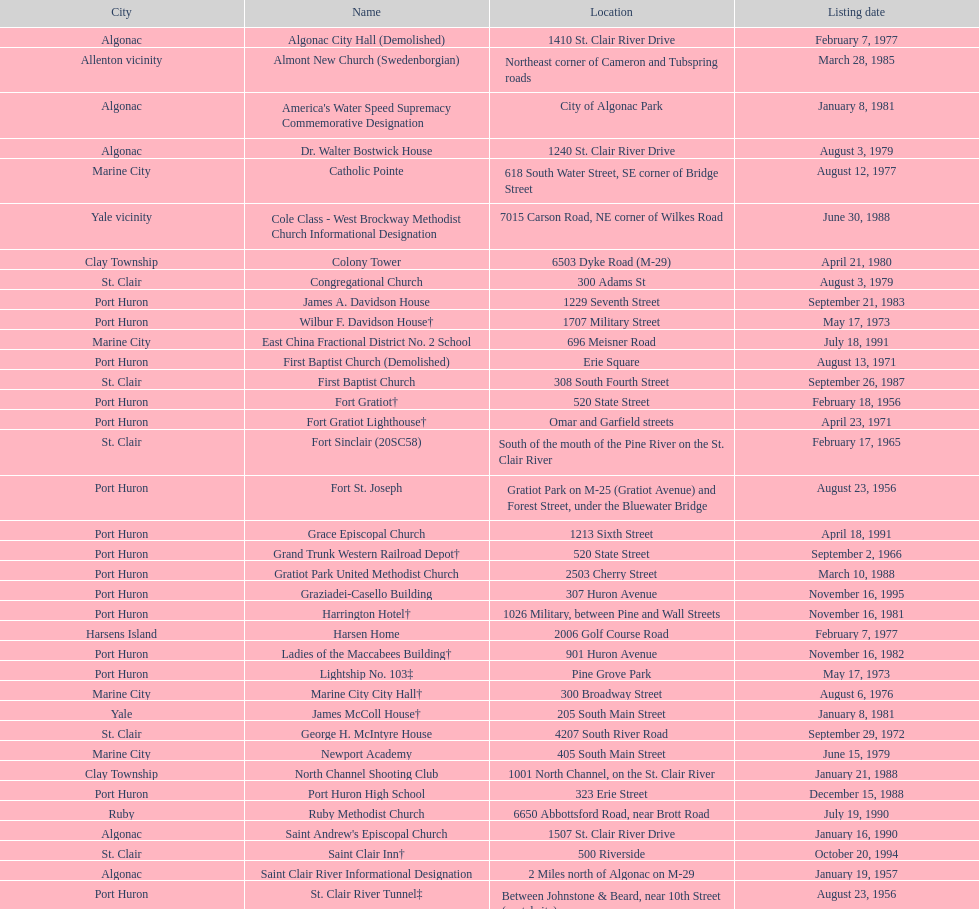What is the number of properties on the list that have been demolished? 2. 